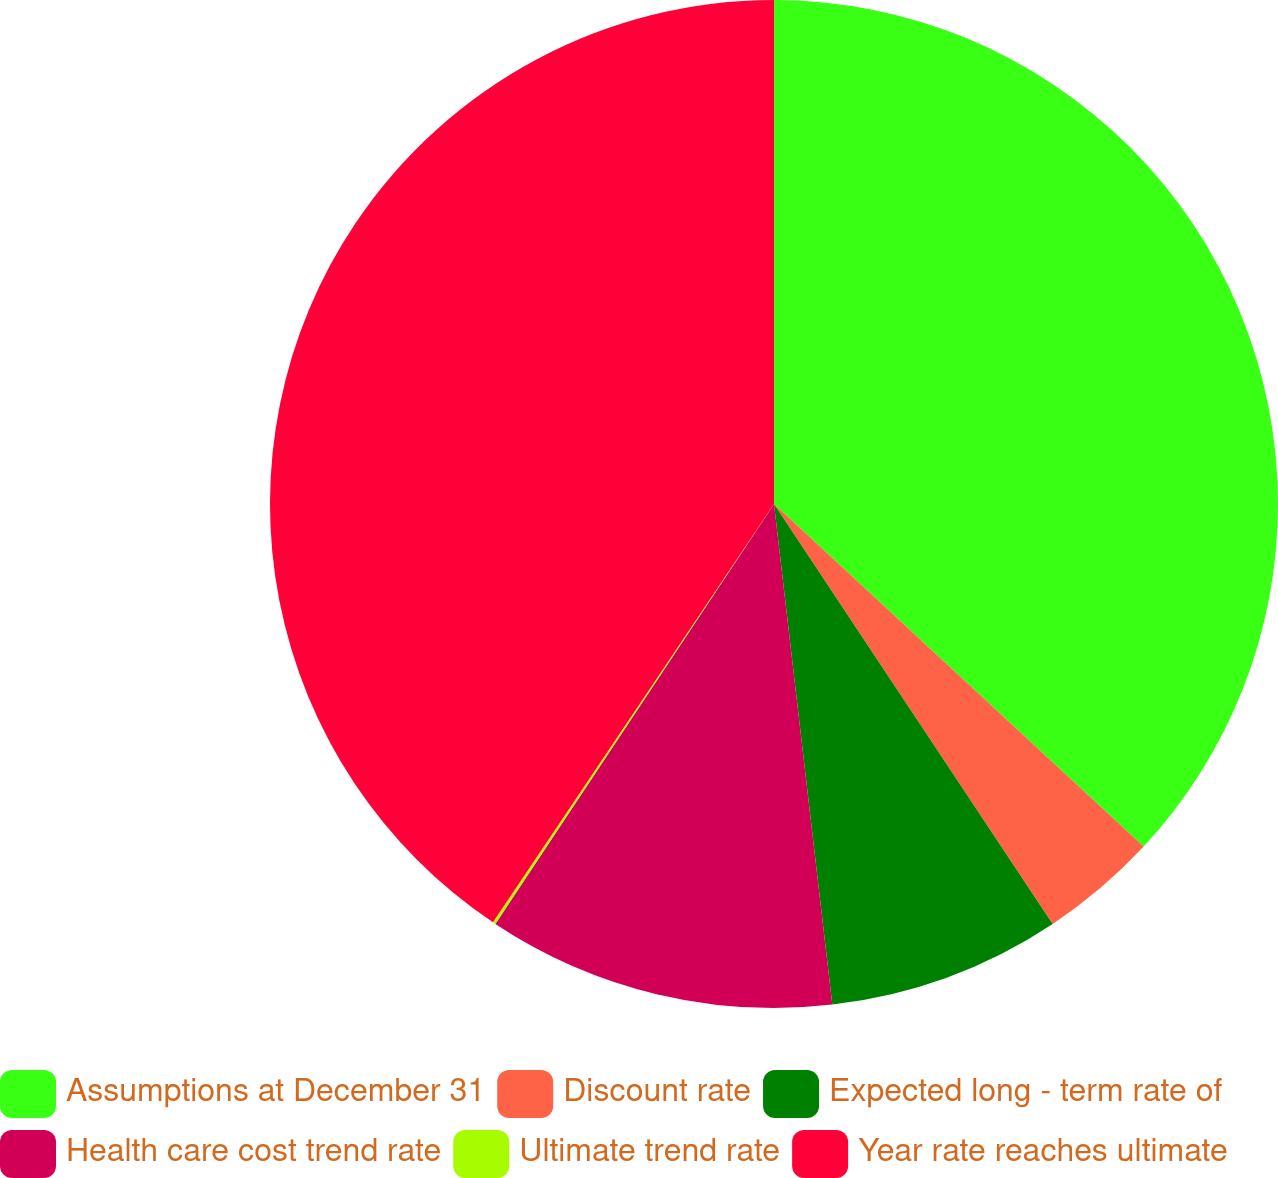Convert chart. <chart><loc_0><loc_0><loc_500><loc_500><pie_chart><fcel>Assumptions at December 31<fcel>Discount rate<fcel>Expected long - term rate of<fcel>Health care cost trend rate<fcel>Ultimate trend rate<fcel>Year rate reaches ultimate<nl><fcel>36.9%<fcel>3.78%<fcel>7.48%<fcel>11.17%<fcel>0.09%<fcel>40.59%<nl></chart> 